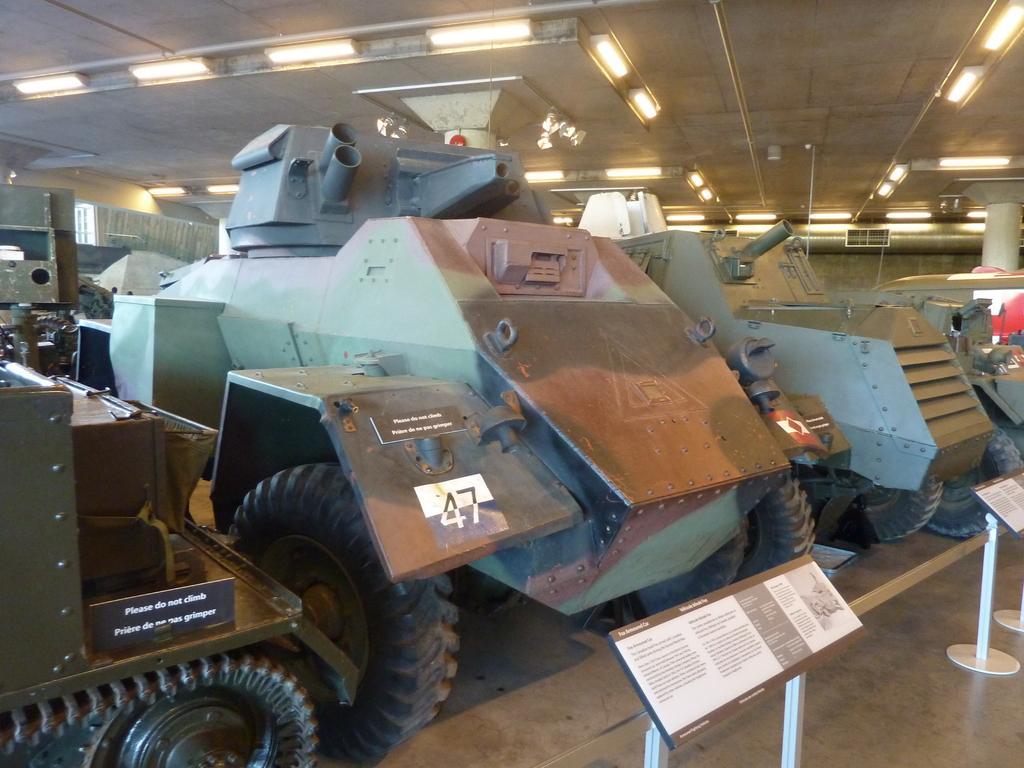Could you give a brief overview of what you see in this image? In this image, we can see war tanks. There are board in the bottom right of the image. There are lights on the ceiling which is at the top of the image. 